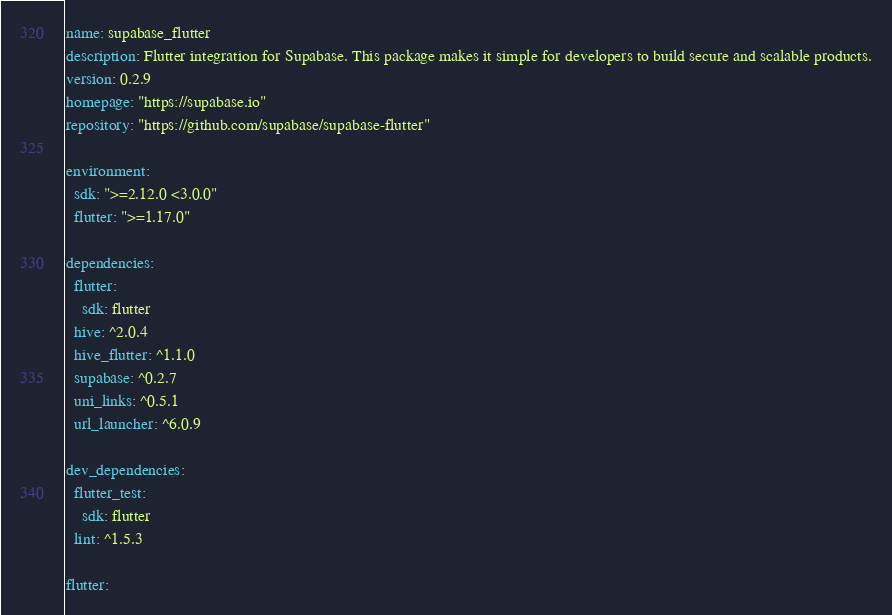Convert code to text. <code><loc_0><loc_0><loc_500><loc_500><_YAML_>name: supabase_flutter
description: Flutter integration for Supabase. This package makes it simple for developers to build secure and scalable products.
version: 0.2.9
homepage: "https://supabase.io"
repository: "https://github.com/supabase/supabase-flutter"

environment:
  sdk: ">=2.12.0 <3.0.0"
  flutter: ">=1.17.0"

dependencies:
  flutter:
    sdk: flutter
  hive: ^2.0.4
  hive_flutter: ^1.1.0
  supabase: ^0.2.7
  uni_links: ^0.5.1
  url_launcher: ^6.0.9

dev_dependencies:
  flutter_test:
    sdk: flutter
  lint: ^1.5.3

flutter:
</code> 